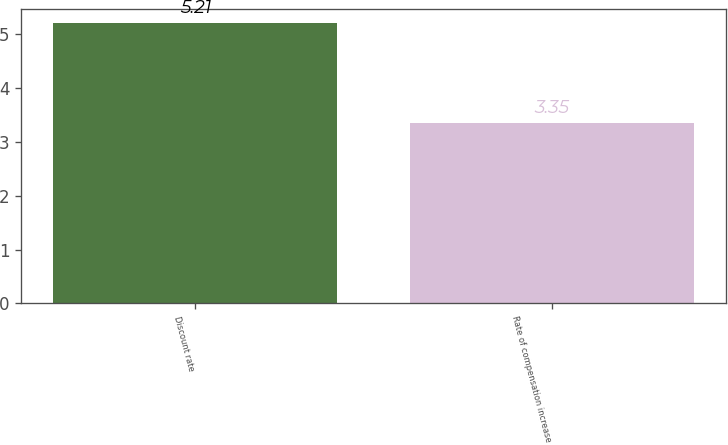Convert chart to OTSL. <chart><loc_0><loc_0><loc_500><loc_500><bar_chart><fcel>Discount rate<fcel>Rate of compensation increase<nl><fcel>5.21<fcel>3.35<nl></chart> 